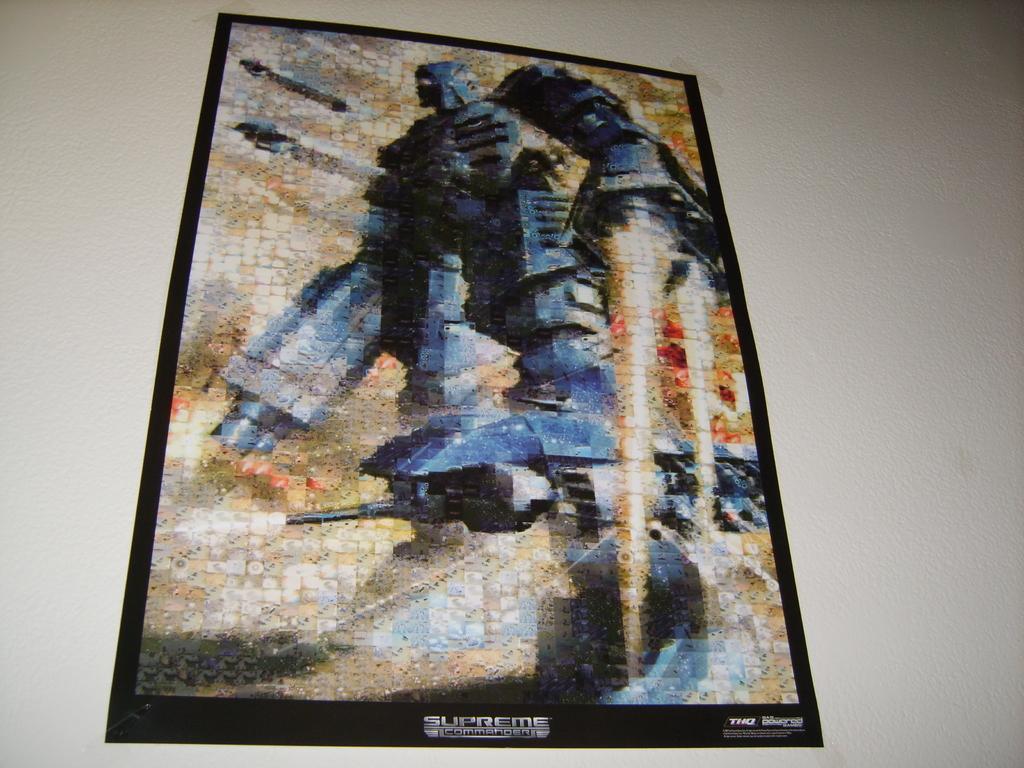In one or two sentences, can you explain what this image depicts? Here in this picture we can see a poster present on the wall over there and in that poster we can see a robot present over there. 